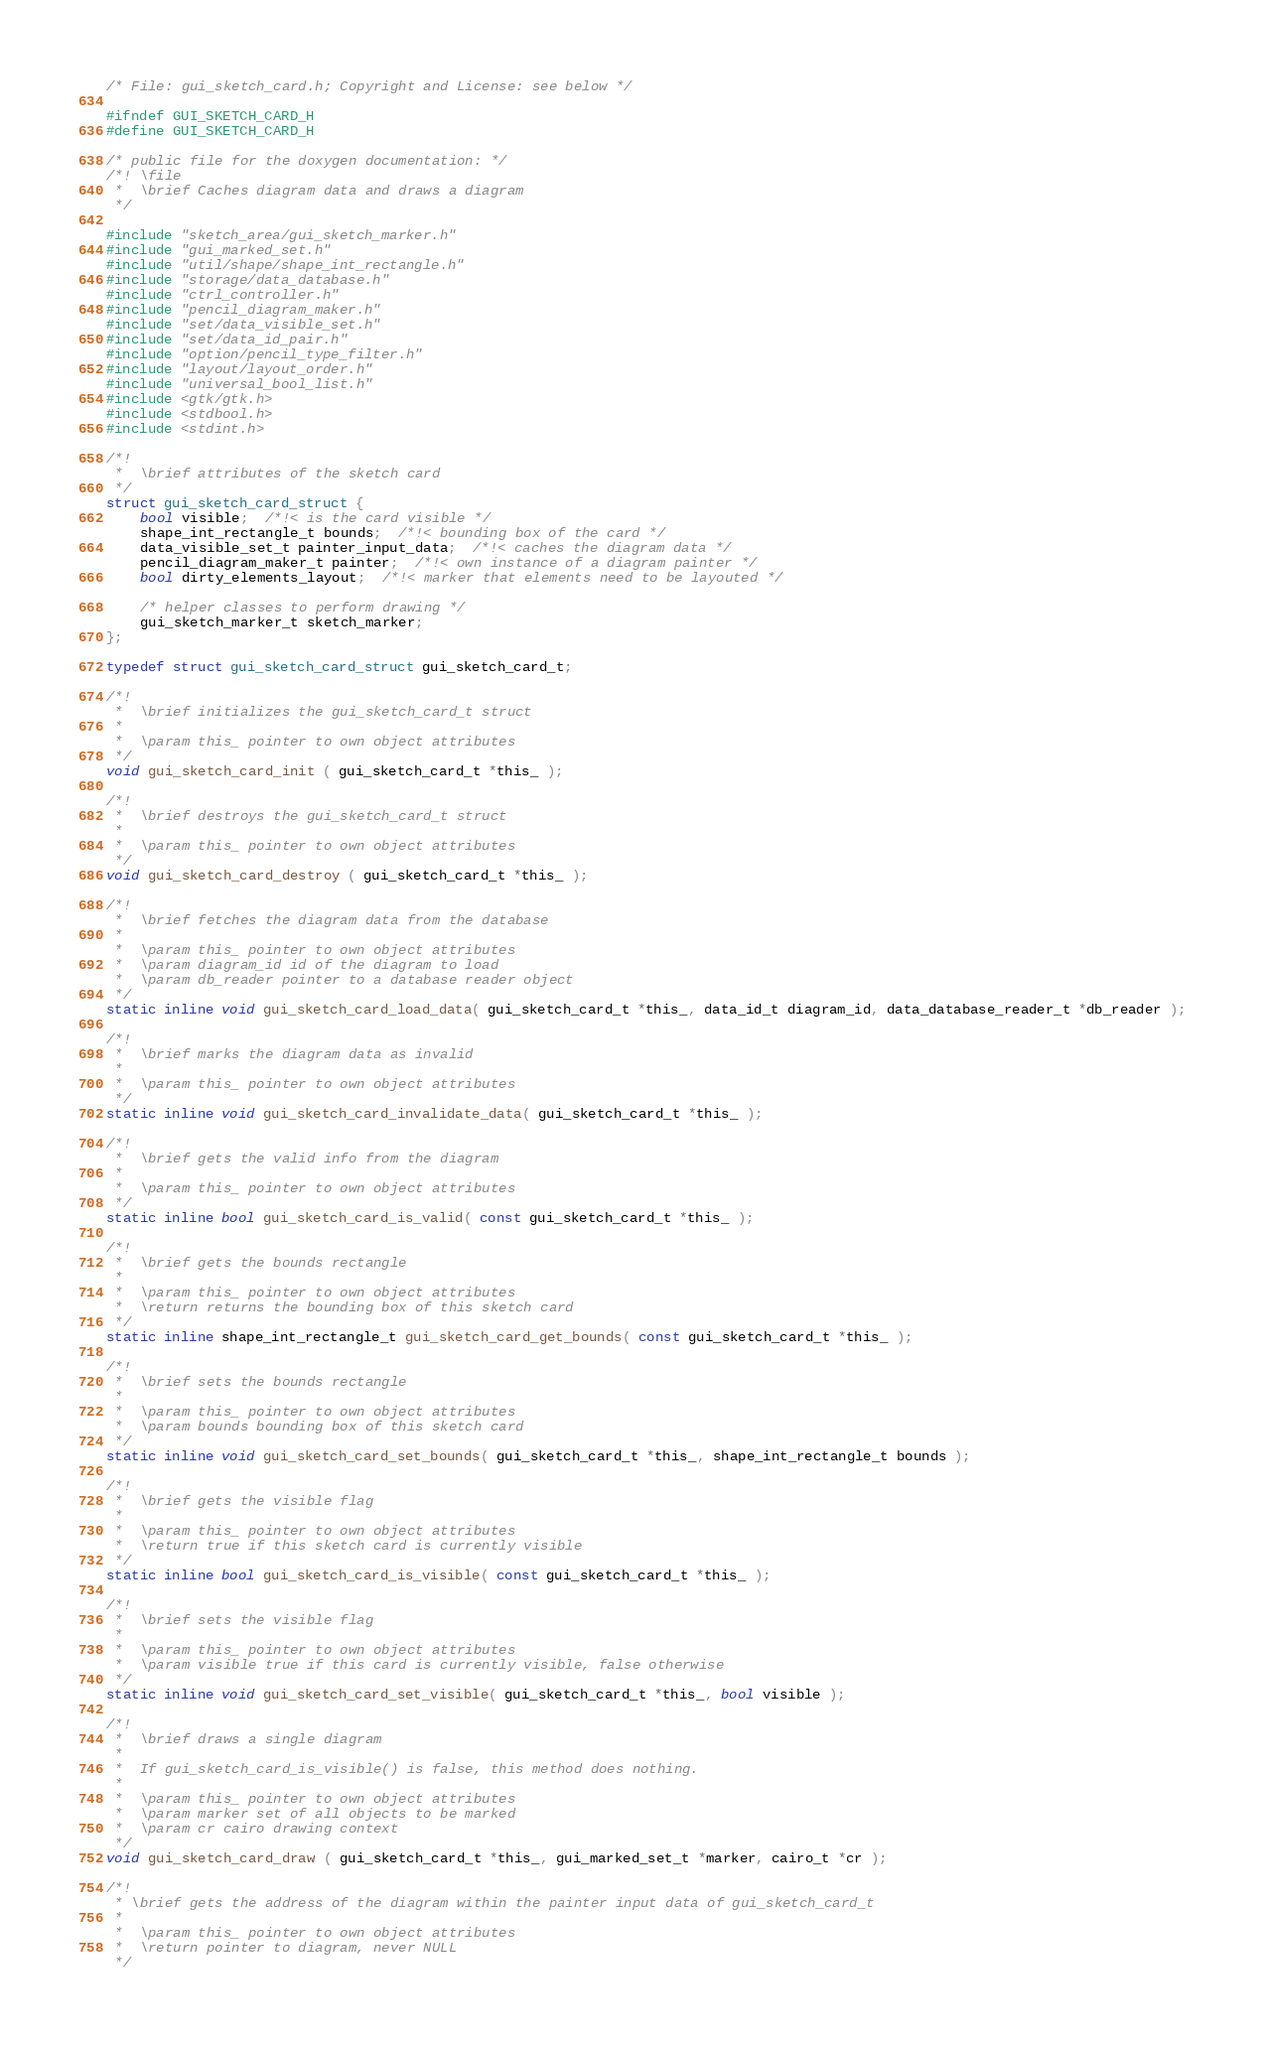<code> <loc_0><loc_0><loc_500><loc_500><_C_>/* File: gui_sketch_card.h; Copyright and License: see below */

#ifndef GUI_SKETCH_CARD_H
#define GUI_SKETCH_CARD_H

/* public file for the doxygen documentation: */
/*! \file
 *  \brief Caches diagram data and draws a diagram
 */

#include "sketch_area/gui_sketch_marker.h"
#include "gui_marked_set.h"
#include "util/shape/shape_int_rectangle.h"
#include "storage/data_database.h"
#include "ctrl_controller.h"
#include "pencil_diagram_maker.h"
#include "set/data_visible_set.h"
#include "set/data_id_pair.h"
#include "option/pencil_type_filter.h"
#include "layout/layout_order.h"
#include "universal_bool_list.h"
#include <gtk/gtk.h>
#include <stdbool.h>
#include <stdint.h>

/*!
 *  \brief attributes of the sketch card
 */
struct gui_sketch_card_struct {
    bool visible;  /*!< is the card visible */
    shape_int_rectangle_t bounds;  /*!< bounding box of the card */
    data_visible_set_t painter_input_data;  /*!< caches the diagram data */
    pencil_diagram_maker_t painter;  /*!< own instance of a diagram painter */
    bool dirty_elements_layout;  /*!< marker that elements need to be layouted */
    
    /* helper classes to perform drawing */
    gui_sketch_marker_t sketch_marker;
};

typedef struct gui_sketch_card_struct gui_sketch_card_t;

/*!
 *  \brief initializes the gui_sketch_card_t struct
 *
 *  \param this_ pointer to own object attributes
 */
void gui_sketch_card_init ( gui_sketch_card_t *this_ );

/*!
 *  \brief destroys the gui_sketch_card_t struct
 *
 *  \param this_ pointer to own object attributes
 */
void gui_sketch_card_destroy ( gui_sketch_card_t *this_ );

/*!
 *  \brief fetches the diagram data from the database
 *
 *  \param this_ pointer to own object attributes
 *  \param diagram_id id of the diagram to load
 *  \param db_reader pointer to a database reader object
 */
static inline void gui_sketch_card_load_data( gui_sketch_card_t *this_, data_id_t diagram_id, data_database_reader_t *db_reader );

/*!
 *  \brief marks the diagram data as invalid
 *
 *  \param this_ pointer to own object attributes
 */
static inline void gui_sketch_card_invalidate_data( gui_sketch_card_t *this_ );

/*!
 *  \brief gets the valid info from the diagram
 *
 *  \param this_ pointer to own object attributes
 */
static inline bool gui_sketch_card_is_valid( const gui_sketch_card_t *this_ );

/*!
 *  \brief gets the bounds rectangle
 *
 *  \param this_ pointer to own object attributes
 *  \return returns the bounding box of this sketch card
 */
static inline shape_int_rectangle_t gui_sketch_card_get_bounds( const gui_sketch_card_t *this_ );

/*!
 *  \brief sets the bounds rectangle
 *
 *  \param this_ pointer to own object attributes
 *  \param bounds bounding box of this sketch card
 */
static inline void gui_sketch_card_set_bounds( gui_sketch_card_t *this_, shape_int_rectangle_t bounds );

/*!
 *  \brief gets the visible flag
 *
 *  \param this_ pointer to own object attributes
 *  \return true if this sketch card is currently visible
 */
static inline bool gui_sketch_card_is_visible( const gui_sketch_card_t *this_ );

/*!
 *  \brief sets the visible flag
 *
 *  \param this_ pointer to own object attributes
 *  \param visible true if this card is currently visible, false otherwise
 */
static inline void gui_sketch_card_set_visible( gui_sketch_card_t *this_, bool visible );

/*!
 *  \brief draws a single diagram
 *
 *  If gui_sketch_card_is_visible() is false, this method does nothing.
 *
 *  \param this_ pointer to own object attributes
 *  \param marker set of all objects to be marked
 *  \param cr cairo drawing context
 */
void gui_sketch_card_draw ( gui_sketch_card_t *this_, gui_marked_set_t *marker, cairo_t *cr );

/*!
 * \brief gets the address of the diagram within the painter input data of gui_sketch_card_t
 *
 *  \param this_ pointer to own object attributes
 *  \return pointer to diagram, never NULL
 */</code> 